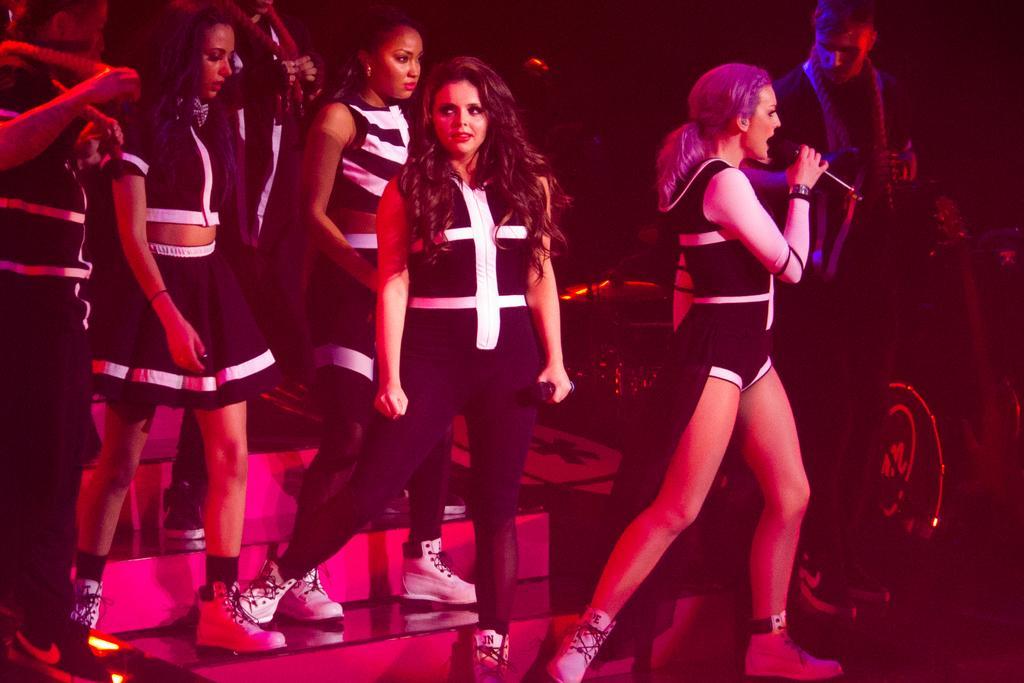Please provide a concise description of this image. In this picture I can see few people standing and a woman holding a microphone in her hand and singing and few people standing on the side. 